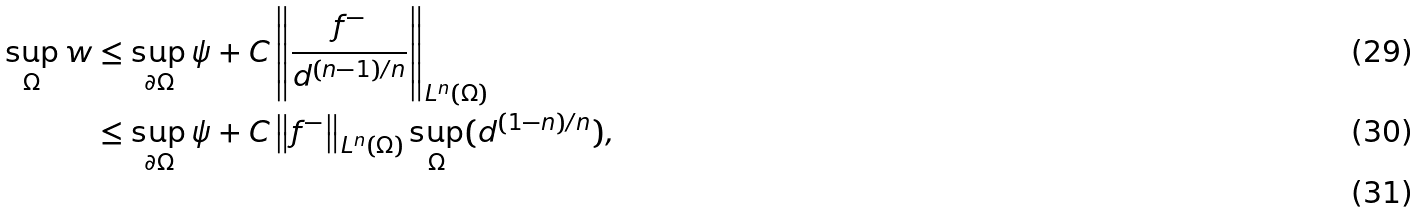<formula> <loc_0><loc_0><loc_500><loc_500>\sup _ { \Omega } w & \leq \sup _ { \partial \Omega } \psi + C \left \| \frac { f ^ { - } } { d ^ { ( n - 1 ) / n } } \right \| _ { L ^ { n } ( \Omega ) } \\ & \leq \sup _ { \partial \Omega } \psi + C \left \| f ^ { - } \right \| _ { L ^ { n } ( \Omega ) } \sup _ { \Omega } ( d ^ { ( 1 - n ) / n } ) , \\</formula> 